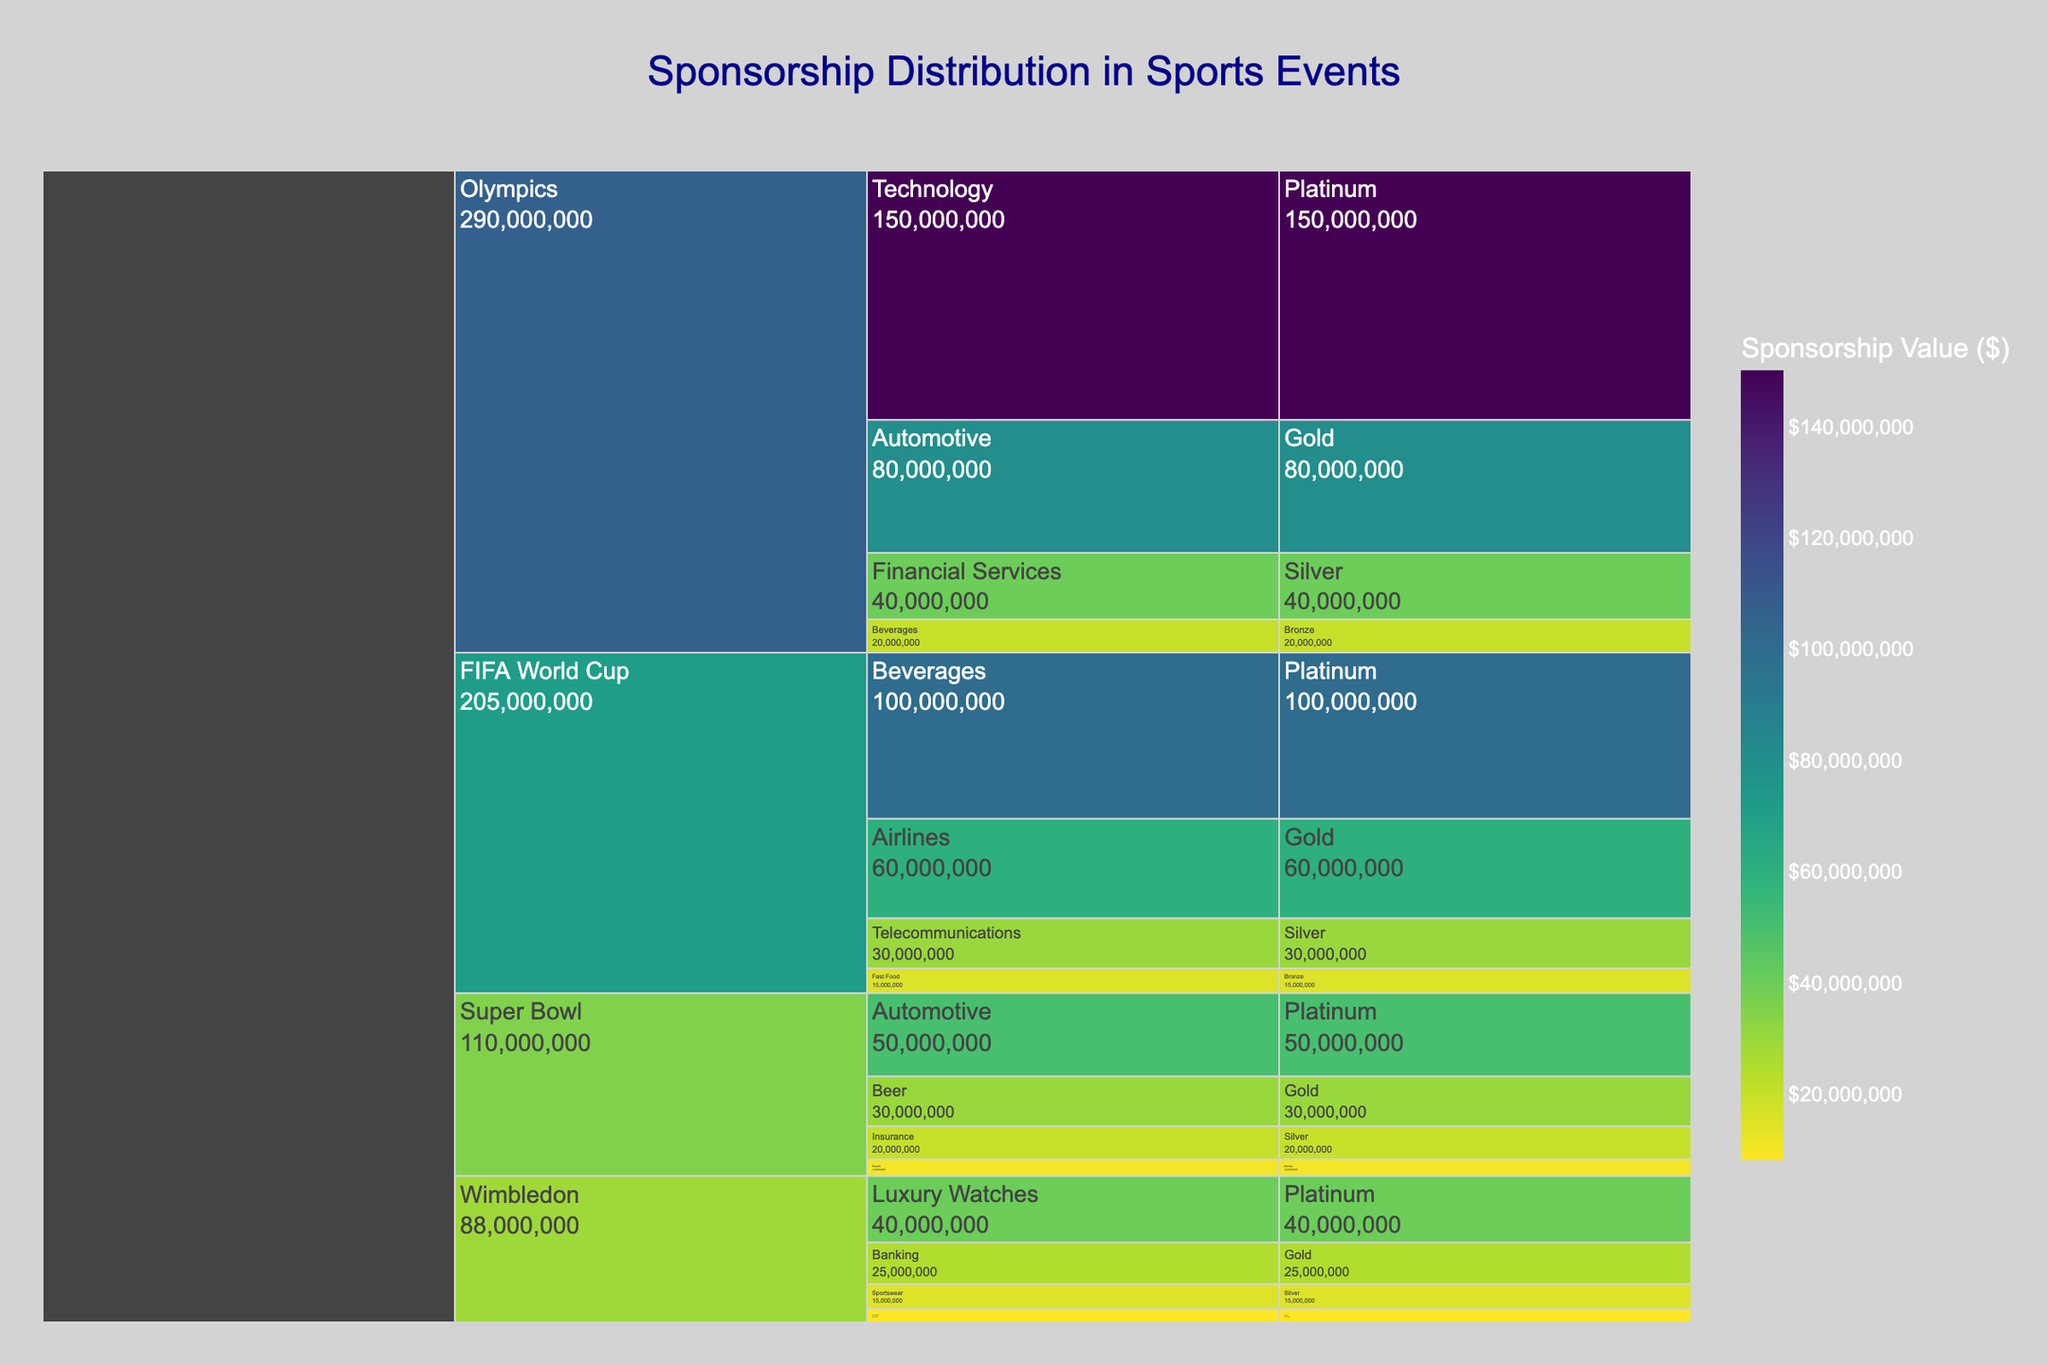What is the title of the chart? The title of the chart is located at the top center of the figure. It reads "Sponsorship Distribution in Sports Events".
Answer: Sponsorship Distribution in Sports Events Which sport has the highest total sponsorship value? By looking at the size of the segments for each sport at the top of the icicle chart, the Olympics segment appears to be the largest.
Answer: Olympics How much is the Platinum sponsorship value for the FIFA World Cup? Look at the FIFA World Cup section and find the Platinum segment under it. The hover information shows the amount is $100,000,000.
Answer: $100,000,000 Between Technology and Beverages, which industry has higher sponsorship value for the Olympics? In the Olympics section, compare the Platinum segment for Technology ($150,000,000) with the Bronze segment for Beverages ($20,000,000). Technology has a higher value.
Answer: Technology What is the combined sponsorship value for Gold tier in all sports? Add the Gold tier values for all sports events: $80,000,000 (Olympics) + $60,000,000 (FIFA World Cup) + $30,000,000 (Super Bowl) + $25,000,000 (Wimbledon) = $195,000,000.
Answer: $195,000,000 Which tier has the lowest sponsorship value for Wimbledon? Examine the Wimbledon section and identify the values for all tiers: Platinum ($40,000,000), Gold ($25,000,000), Silver ($15,000,000), and Bronze ($8,000,000). Bronze has the lowest value.
Answer: Bronze Compare the total sponsorship value of the Olympics and the Super Bowl. Which one is higher and by how much? Add the sponsorship values for each tier in both events:
Olympics: $150,000,000 (Platinum) + $80,000,000 (Gold) + $40,000,000 (Silver) + $20,000,000 (Bronze) = $290,000,000.
Super Bowl: $50,000,000 (Platinum) + $30,000,000 (Gold) + $20,000,000 (Silver) + $10,000,000 (Bronze) = $110,000,000.
The Olympics have a higher total by $290,000,000 - $110,000,000 = $180,000,000.
Answer: Olympics, $180,000,000 What is the sum of Platinum tier sponsorship values across all sports? Add the Platinum values for each sport: $150,000,000 (Olympics) + $100,000,000 (FIFA World Cup) + $50,000,000 (Super Bowl) + $40,000,000 (Wimbledon) = $340,000,000.
Answer: $340,000,000 How does the Silver tier sponsorship value of Wimbledon compare to that of the Super Bowl? Look at the Silver tier values for both:
Super Bowl: $20,000,000
Wimbledon: $15,000,000
The Super Bowl has a higher value by $5,000,000.
Answer: Super Bowl by $5,000,000 Which industry sponsors multiple sports events, and what is the total value of their sponsorships? Identify industries appearing in multiple sports events. Beverages sponsors both the Olympics (Bronze, $20,000,000) and the FIFA World Cup (Platinum, $100,000,000). Total = $20,000,000 + $100,000,000 = $120,000,000.
Answer: Beverages, $120,000,000 